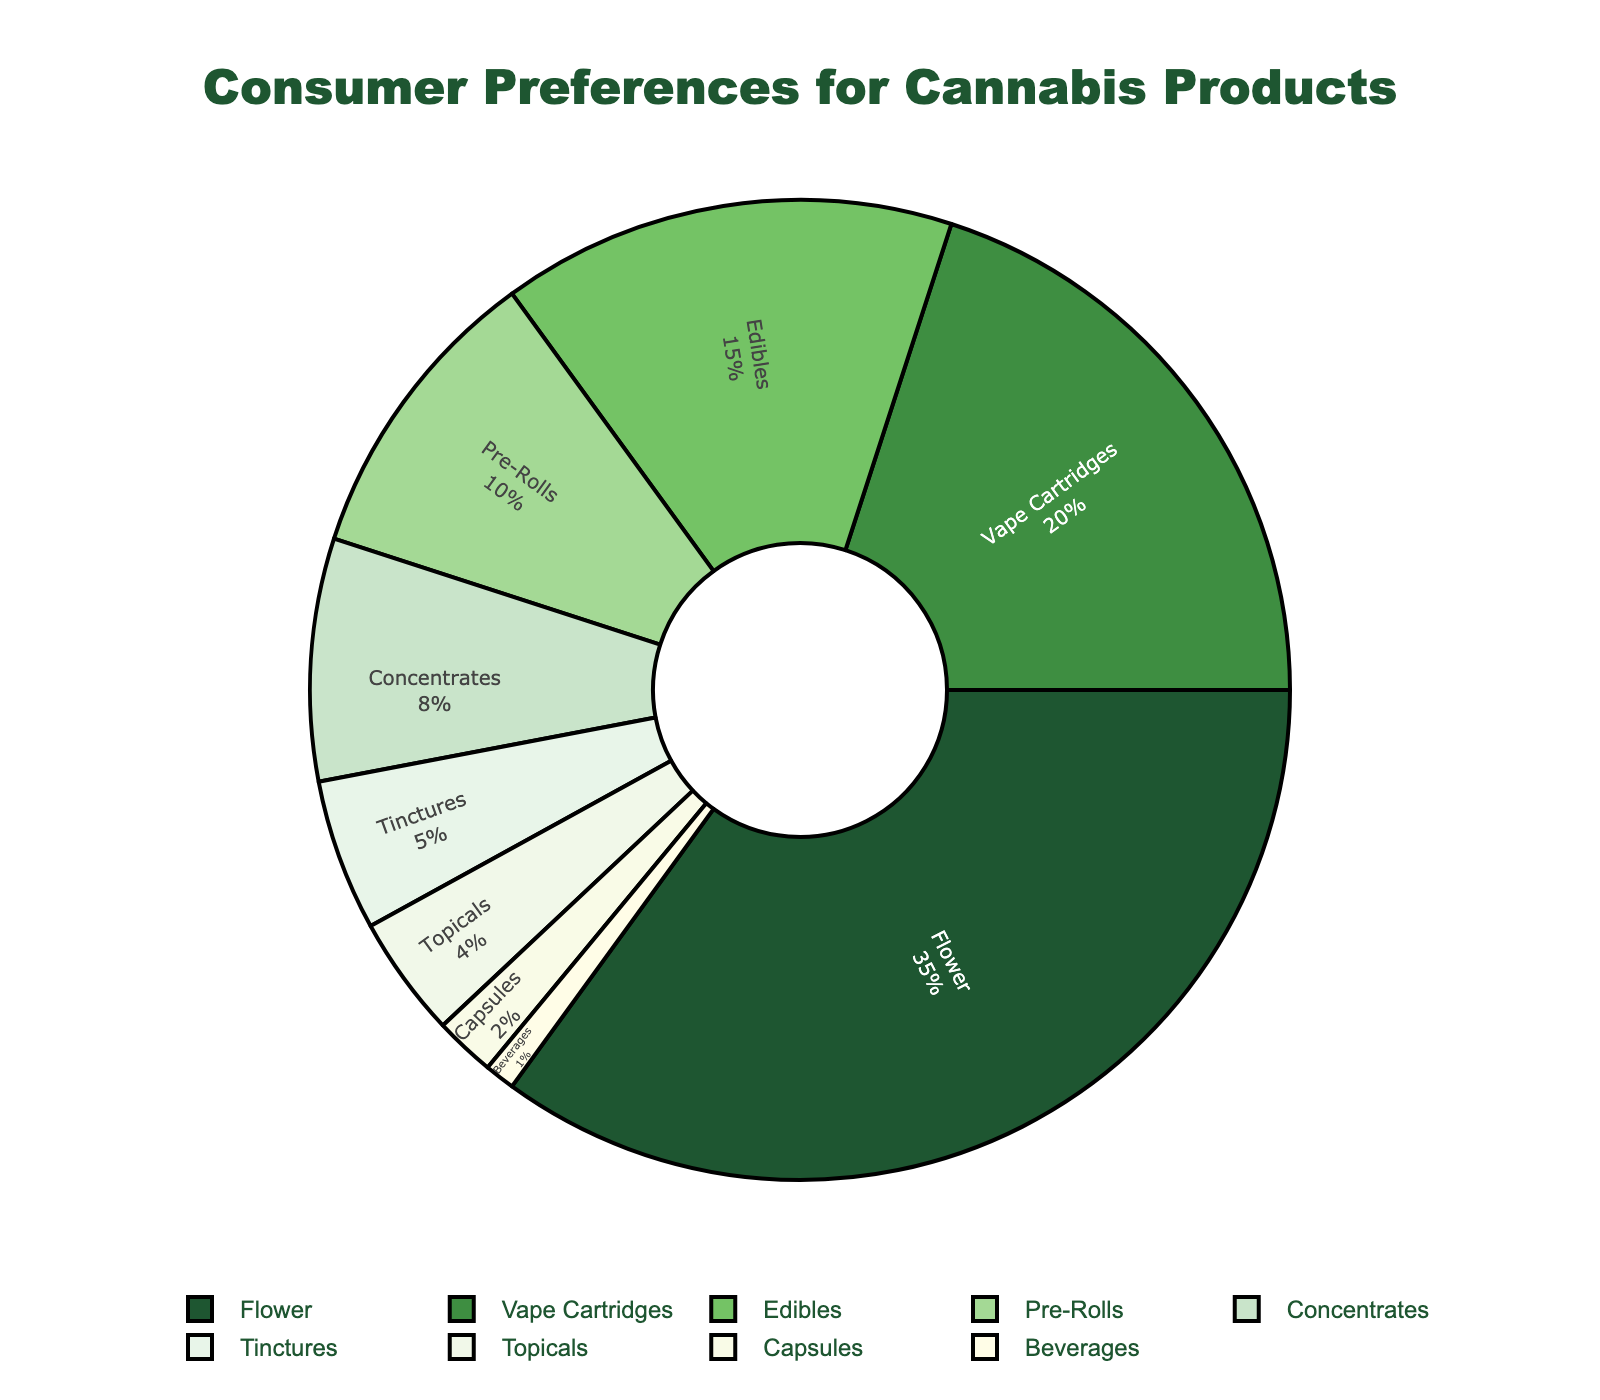what percentage of consumers prefer flower products compared to vape cartridges? The pie chart shows that flower products are preferred by 35% of consumers while vape cartridges are preferred by 20%. Subtracting these percentages gives: 35% - 20% = 15%.
Answer: 15% Which product category has the lowest consumer preference? The pie chart shows that beverages have the lowest consumer preference at 1%.
Answer: Beverages What is the combined percentage of preferences for edibles and tinctures? The pie chart shows that edibles are at 15% and tinctures at 5%. Adding these two percentages gives: 15% + 5% = 20%.
Answer: 20% How do the consumer preferences for pre-rolls compare to that of concentrates? The pie chart shows pre-rolls have a 10% preference, while concentrates have 8%. Subtracting these gives: 10% - 8% = 2%.
Answer: 2% What is the most preferred cannabis product? The pie chart shows that flower products have the highest percentage at 35%.
Answer: Flower Compare the combined preferences for topicals and capsules to that of vapes cartridges. The pie chart shows topicals (4%) and capsules (2%), which together are 6%. Vapes cartridges are at 20%. Thus, 6% is less than 20%.
Answer: 6% is less than 20% Which category's preference is closest to the average preference of all categories? Add the percentages and divide by the number of categories: (35+20+15+10+8+5+4+2+1)/9 = 100/9 ≈ 11.1%. Pre-rolls at 10% are closest to this average.
Answer: Pre-Rolls What percentage of consumer preferences go towards products other than the top three categories? The top three categories are flower (35%), vape cartridges (20%), and edibles (15%), totaling 70%. The other categories total: 100% - 70% = 30%.
Answer: 30% If the percentage for capsules was doubled, how would it compare to tinctures? Capsules currently stand at 2%. Doubling this gives 2 x 2 = 4%, which is still less than tinctures at 5%.
Answer: 4% is less than 5% Which three products have the smallest consumer preferences, and what is their combined percentage? The least three preferred products are capsules (2%), beverages (1%), and topicals (4%). Their combined percentage is: 2% + 1% + 4% = 7%.
Answer: 7% 